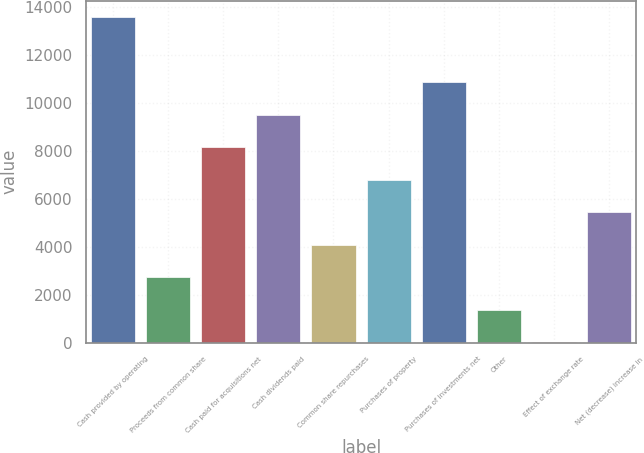Convert chart to OTSL. <chart><loc_0><loc_0><loc_500><loc_500><bar_chart><fcel>Cash provided by operating<fcel>Proceeds from common share<fcel>Cash paid for acquisitions net<fcel>Cash dividends paid<fcel>Common share repurchases<fcel>Purchases of property<fcel>Purchases of investments net<fcel>Other<fcel>Effect of exchange rate<fcel>Net (decrease) increase in<nl><fcel>13596<fcel>2723.2<fcel>8159.6<fcel>9518.7<fcel>4082.3<fcel>6800.5<fcel>10877.8<fcel>1364.1<fcel>5<fcel>5441.4<nl></chart> 